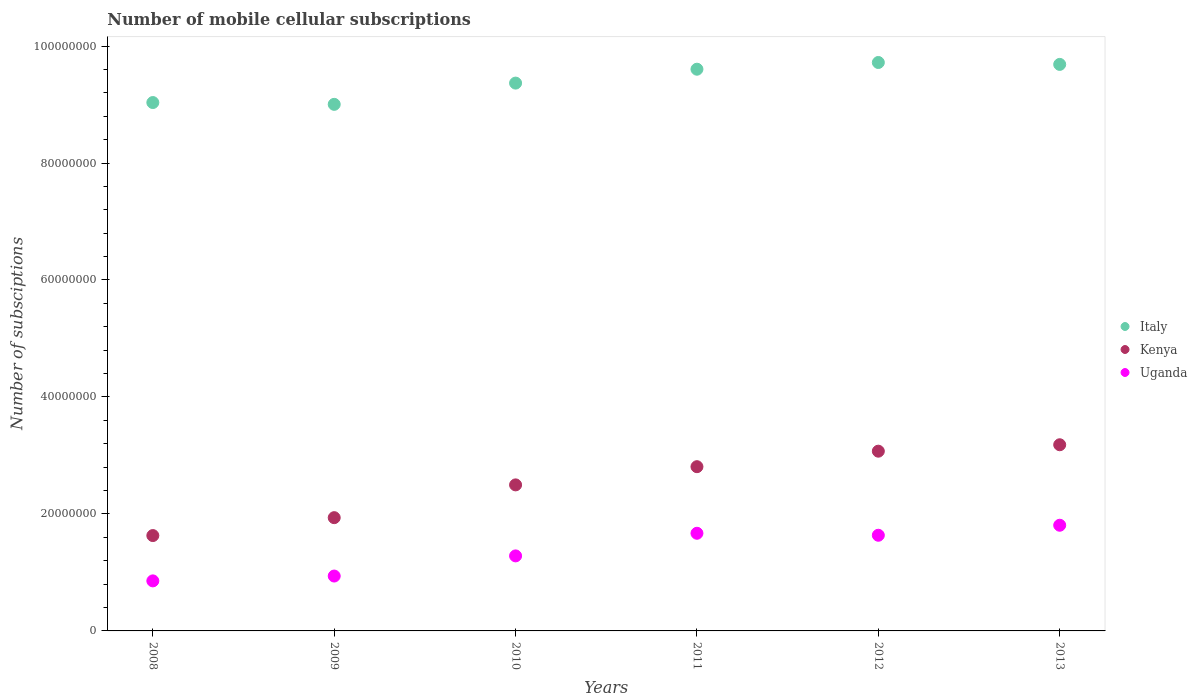How many different coloured dotlines are there?
Offer a very short reply. 3. What is the number of mobile cellular subscriptions in Uganda in 2010?
Keep it short and to the point. 1.28e+07. Across all years, what is the maximum number of mobile cellular subscriptions in Uganda?
Provide a succinct answer. 1.81e+07. Across all years, what is the minimum number of mobile cellular subscriptions in Uganda?
Make the answer very short. 8.55e+06. In which year was the number of mobile cellular subscriptions in Italy minimum?
Give a very brief answer. 2009. What is the total number of mobile cellular subscriptions in Italy in the graph?
Make the answer very short. 5.64e+08. What is the difference between the number of mobile cellular subscriptions in Uganda in 2008 and that in 2013?
Offer a terse response. -9.51e+06. What is the difference between the number of mobile cellular subscriptions in Kenya in 2013 and the number of mobile cellular subscriptions in Uganda in 2009?
Your answer should be very brief. 2.24e+07. What is the average number of mobile cellular subscriptions in Italy per year?
Your response must be concise. 9.40e+07. In the year 2012, what is the difference between the number of mobile cellular subscriptions in Kenya and number of mobile cellular subscriptions in Italy?
Provide a succinct answer. -6.65e+07. In how many years, is the number of mobile cellular subscriptions in Uganda greater than 40000000?
Provide a succinct answer. 0. What is the ratio of the number of mobile cellular subscriptions in Kenya in 2010 to that in 2013?
Give a very brief answer. 0.78. Is the number of mobile cellular subscriptions in Kenya in 2008 less than that in 2010?
Your answer should be very brief. Yes. What is the difference between the highest and the second highest number of mobile cellular subscriptions in Uganda?
Keep it short and to the point. 1.37e+06. What is the difference between the highest and the lowest number of mobile cellular subscriptions in Italy?
Keep it short and to the point. 7.16e+06. In how many years, is the number of mobile cellular subscriptions in Kenya greater than the average number of mobile cellular subscriptions in Kenya taken over all years?
Offer a very short reply. 3. Is the sum of the number of mobile cellular subscriptions in Uganda in 2011 and 2013 greater than the maximum number of mobile cellular subscriptions in Italy across all years?
Keep it short and to the point. No. Is it the case that in every year, the sum of the number of mobile cellular subscriptions in Italy and number of mobile cellular subscriptions in Kenya  is greater than the number of mobile cellular subscriptions in Uganda?
Offer a terse response. Yes. Does the number of mobile cellular subscriptions in Uganda monotonically increase over the years?
Your answer should be compact. No. Is the number of mobile cellular subscriptions in Italy strictly less than the number of mobile cellular subscriptions in Uganda over the years?
Provide a short and direct response. No. How many years are there in the graph?
Your response must be concise. 6. What is the difference between two consecutive major ticks on the Y-axis?
Offer a terse response. 2.00e+07. Are the values on the major ticks of Y-axis written in scientific E-notation?
Keep it short and to the point. No. Does the graph contain any zero values?
Your answer should be very brief. No. How many legend labels are there?
Offer a very short reply. 3. What is the title of the graph?
Provide a succinct answer. Number of mobile cellular subscriptions. What is the label or title of the X-axis?
Provide a short and direct response. Years. What is the label or title of the Y-axis?
Give a very brief answer. Number of subsciptions. What is the Number of subsciptions of Italy in 2008?
Provide a succinct answer. 9.03e+07. What is the Number of subsciptions in Kenya in 2008?
Your answer should be compact. 1.63e+07. What is the Number of subsciptions in Uganda in 2008?
Provide a succinct answer. 8.55e+06. What is the Number of subsciptions of Italy in 2009?
Offer a very short reply. 9.00e+07. What is the Number of subsciptions of Kenya in 2009?
Make the answer very short. 1.94e+07. What is the Number of subsciptions of Uganda in 2009?
Ensure brevity in your answer.  9.38e+06. What is the Number of subsciptions of Italy in 2010?
Your answer should be compact. 9.37e+07. What is the Number of subsciptions of Kenya in 2010?
Provide a succinct answer. 2.50e+07. What is the Number of subsciptions in Uganda in 2010?
Provide a succinct answer. 1.28e+07. What is the Number of subsciptions of Italy in 2011?
Your response must be concise. 9.60e+07. What is the Number of subsciptions in Kenya in 2011?
Provide a short and direct response. 2.81e+07. What is the Number of subsciptions in Uganda in 2011?
Give a very brief answer. 1.67e+07. What is the Number of subsciptions in Italy in 2012?
Your answer should be compact. 9.72e+07. What is the Number of subsciptions of Kenya in 2012?
Ensure brevity in your answer.  3.07e+07. What is the Number of subsciptions of Uganda in 2012?
Your answer should be very brief. 1.64e+07. What is the Number of subsciptions in Italy in 2013?
Make the answer very short. 9.69e+07. What is the Number of subsciptions of Kenya in 2013?
Keep it short and to the point. 3.18e+07. What is the Number of subsciptions of Uganda in 2013?
Your response must be concise. 1.81e+07. Across all years, what is the maximum Number of subsciptions in Italy?
Offer a very short reply. 9.72e+07. Across all years, what is the maximum Number of subsciptions of Kenya?
Your answer should be compact. 3.18e+07. Across all years, what is the maximum Number of subsciptions in Uganda?
Your answer should be very brief. 1.81e+07. Across all years, what is the minimum Number of subsciptions in Italy?
Your answer should be very brief. 9.00e+07. Across all years, what is the minimum Number of subsciptions of Kenya?
Offer a very short reply. 1.63e+07. Across all years, what is the minimum Number of subsciptions in Uganda?
Provide a short and direct response. 8.55e+06. What is the total Number of subsciptions of Italy in the graph?
Your response must be concise. 5.64e+08. What is the total Number of subsciptions in Kenya in the graph?
Keep it short and to the point. 1.51e+08. What is the total Number of subsciptions of Uganda in the graph?
Offer a very short reply. 8.19e+07. What is the difference between the Number of subsciptions in Italy in 2008 and that in 2009?
Your answer should be very brief. 3.08e+05. What is the difference between the Number of subsciptions in Kenya in 2008 and that in 2009?
Give a very brief answer. -3.06e+06. What is the difference between the Number of subsciptions in Uganda in 2008 and that in 2009?
Offer a terse response. -8.29e+05. What is the difference between the Number of subsciptions of Italy in 2008 and that in 2010?
Keep it short and to the point. -3.33e+06. What is the difference between the Number of subsciptions in Kenya in 2008 and that in 2010?
Provide a short and direct response. -8.67e+06. What is the difference between the Number of subsciptions in Uganda in 2008 and that in 2010?
Your response must be concise. -4.27e+06. What is the difference between the Number of subsciptions of Italy in 2008 and that in 2011?
Your answer should be very brief. -5.70e+06. What is the difference between the Number of subsciptions in Kenya in 2008 and that in 2011?
Your response must be concise. -1.18e+07. What is the difference between the Number of subsciptions in Uganda in 2008 and that in 2011?
Make the answer very short. -8.14e+06. What is the difference between the Number of subsciptions in Italy in 2008 and that in 2012?
Provide a short and direct response. -6.85e+06. What is the difference between the Number of subsciptions of Kenya in 2008 and that in 2012?
Give a very brief answer. -1.44e+07. What is the difference between the Number of subsciptions of Uganda in 2008 and that in 2012?
Your answer should be very brief. -7.80e+06. What is the difference between the Number of subsciptions of Italy in 2008 and that in 2013?
Your answer should be very brief. -6.52e+06. What is the difference between the Number of subsciptions of Kenya in 2008 and that in 2013?
Your answer should be compact. -1.55e+07. What is the difference between the Number of subsciptions in Uganda in 2008 and that in 2013?
Your answer should be compact. -9.51e+06. What is the difference between the Number of subsciptions of Italy in 2009 and that in 2010?
Your answer should be compact. -3.63e+06. What is the difference between the Number of subsciptions in Kenya in 2009 and that in 2010?
Ensure brevity in your answer.  -5.60e+06. What is the difference between the Number of subsciptions in Uganda in 2009 and that in 2010?
Provide a succinct answer. -3.44e+06. What is the difference between the Number of subsciptions of Italy in 2009 and that in 2011?
Make the answer very short. -6.01e+06. What is the difference between the Number of subsciptions in Kenya in 2009 and that in 2011?
Your answer should be compact. -8.72e+06. What is the difference between the Number of subsciptions of Uganda in 2009 and that in 2011?
Ensure brevity in your answer.  -7.31e+06. What is the difference between the Number of subsciptions in Italy in 2009 and that in 2012?
Make the answer very short. -7.16e+06. What is the difference between the Number of subsciptions in Kenya in 2009 and that in 2012?
Provide a succinct answer. -1.14e+07. What is the difference between the Number of subsciptions in Uganda in 2009 and that in 2012?
Give a very brief answer. -6.97e+06. What is the difference between the Number of subsciptions in Italy in 2009 and that in 2013?
Your answer should be very brief. -6.83e+06. What is the difference between the Number of subsciptions in Kenya in 2009 and that in 2013?
Offer a terse response. -1.25e+07. What is the difference between the Number of subsciptions in Uganda in 2009 and that in 2013?
Your answer should be very brief. -8.68e+06. What is the difference between the Number of subsciptions of Italy in 2010 and that in 2011?
Keep it short and to the point. -2.37e+06. What is the difference between the Number of subsciptions of Kenya in 2010 and that in 2011?
Your answer should be compact. -3.11e+06. What is the difference between the Number of subsciptions of Uganda in 2010 and that in 2011?
Your response must be concise. -3.87e+06. What is the difference between the Number of subsciptions in Italy in 2010 and that in 2012?
Keep it short and to the point. -3.52e+06. What is the difference between the Number of subsciptions of Kenya in 2010 and that in 2012?
Provide a succinct answer. -5.76e+06. What is the difference between the Number of subsciptions in Uganda in 2010 and that in 2012?
Your response must be concise. -3.53e+06. What is the difference between the Number of subsciptions of Italy in 2010 and that in 2013?
Provide a succinct answer. -3.20e+06. What is the difference between the Number of subsciptions of Kenya in 2010 and that in 2013?
Give a very brief answer. -6.86e+06. What is the difference between the Number of subsciptions in Uganda in 2010 and that in 2013?
Provide a succinct answer. -5.24e+06. What is the difference between the Number of subsciptions in Italy in 2011 and that in 2012?
Provide a succinct answer. -1.15e+06. What is the difference between the Number of subsciptions in Kenya in 2011 and that in 2012?
Offer a very short reply. -2.65e+06. What is the difference between the Number of subsciptions of Uganda in 2011 and that in 2012?
Make the answer very short. 3.41e+05. What is the difference between the Number of subsciptions in Italy in 2011 and that in 2013?
Offer a terse response. -8.22e+05. What is the difference between the Number of subsciptions of Kenya in 2011 and that in 2013?
Provide a short and direct response. -3.75e+06. What is the difference between the Number of subsciptions in Uganda in 2011 and that in 2013?
Your answer should be compact. -1.37e+06. What is the difference between the Number of subsciptions in Italy in 2012 and that in 2013?
Keep it short and to the point. 3.26e+05. What is the difference between the Number of subsciptions in Kenya in 2012 and that in 2013?
Your answer should be very brief. -1.10e+06. What is the difference between the Number of subsciptions of Uganda in 2012 and that in 2013?
Provide a succinct answer. -1.71e+06. What is the difference between the Number of subsciptions of Italy in 2008 and the Number of subsciptions of Kenya in 2009?
Your response must be concise. 7.10e+07. What is the difference between the Number of subsciptions of Italy in 2008 and the Number of subsciptions of Uganda in 2009?
Ensure brevity in your answer.  8.10e+07. What is the difference between the Number of subsciptions in Kenya in 2008 and the Number of subsciptions in Uganda in 2009?
Make the answer very short. 6.92e+06. What is the difference between the Number of subsciptions of Italy in 2008 and the Number of subsciptions of Kenya in 2010?
Make the answer very short. 6.54e+07. What is the difference between the Number of subsciptions in Italy in 2008 and the Number of subsciptions in Uganda in 2010?
Keep it short and to the point. 7.75e+07. What is the difference between the Number of subsciptions in Kenya in 2008 and the Number of subsciptions in Uganda in 2010?
Give a very brief answer. 3.48e+06. What is the difference between the Number of subsciptions in Italy in 2008 and the Number of subsciptions in Kenya in 2011?
Provide a succinct answer. 6.23e+07. What is the difference between the Number of subsciptions in Italy in 2008 and the Number of subsciptions in Uganda in 2011?
Offer a very short reply. 7.36e+07. What is the difference between the Number of subsciptions in Kenya in 2008 and the Number of subsciptions in Uganda in 2011?
Ensure brevity in your answer.  -3.93e+05. What is the difference between the Number of subsciptions of Italy in 2008 and the Number of subsciptions of Kenya in 2012?
Give a very brief answer. 5.96e+07. What is the difference between the Number of subsciptions of Italy in 2008 and the Number of subsciptions of Uganda in 2012?
Make the answer very short. 7.40e+07. What is the difference between the Number of subsciptions of Kenya in 2008 and the Number of subsciptions of Uganda in 2012?
Your response must be concise. -5.28e+04. What is the difference between the Number of subsciptions in Italy in 2008 and the Number of subsciptions in Kenya in 2013?
Your response must be concise. 5.85e+07. What is the difference between the Number of subsciptions in Italy in 2008 and the Number of subsciptions in Uganda in 2013?
Offer a very short reply. 7.23e+07. What is the difference between the Number of subsciptions in Kenya in 2008 and the Number of subsciptions in Uganda in 2013?
Give a very brief answer. -1.77e+06. What is the difference between the Number of subsciptions in Italy in 2009 and the Number of subsciptions in Kenya in 2010?
Your answer should be compact. 6.51e+07. What is the difference between the Number of subsciptions in Italy in 2009 and the Number of subsciptions in Uganda in 2010?
Provide a short and direct response. 7.72e+07. What is the difference between the Number of subsciptions in Kenya in 2009 and the Number of subsciptions in Uganda in 2010?
Keep it short and to the point. 6.54e+06. What is the difference between the Number of subsciptions in Italy in 2009 and the Number of subsciptions in Kenya in 2011?
Your answer should be compact. 6.20e+07. What is the difference between the Number of subsciptions of Italy in 2009 and the Number of subsciptions of Uganda in 2011?
Your answer should be very brief. 7.33e+07. What is the difference between the Number of subsciptions of Kenya in 2009 and the Number of subsciptions of Uganda in 2011?
Provide a succinct answer. 2.67e+06. What is the difference between the Number of subsciptions of Italy in 2009 and the Number of subsciptions of Kenya in 2012?
Ensure brevity in your answer.  5.93e+07. What is the difference between the Number of subsciptions in Italy in 2009 and the Number of subsciptions in Uganda in 2012?
Ensure brevity in your answer.  7.37e+07. What is the difference between the Number of subsciptions in Kenya in 2009 and the Number of subsciptions in Uganda in 2012?
Keep it short and to the point. 3.01e+06. What is the difference between the Number of subsciptions in Italy in 2009 and the Number of subsciptions in Kenya in 2013?
Your answer should be compact. 5.82e+07. What is the difference between the Number of subsciptions of Italy in 2009 and the Number of subsciptions of Uganda in 2013?
Give a very brief answer. 7.20e+07. What is the difference between the Number of subsciptions of Kenya in 2009 and the Number of subsciptions of Uganda in 2013?
Your answer should be compact. 1.30e+06. What is the difference between the Number of subsciptions in Italy in 2010 and the Number of subsciptions in Kenya in 2011?
Your response must be concise. 6.56e+07. What is the difference between the Number of subsciptions of Italy in 2010 and the Number of subsciptions of Uganda in 2011?
Your answer should be compact. 7.70e+07. What is the difference between the Number of subsciptions in Kenya in 2010 and the Number of subsciptions in Uganda in 2011?
Give a very brief answer. 8.27e+06. What is the difference between the Number of subsciptions of Italy in 2010 and the Number of subsciptions of Kenya in 2012?
Your response must be concise. 6.29e+07. What is the difference between the Number of subsciptions in Italy in 2010 and the Number of subsciptions in Uganda in 2012?
Your response must be concise. 7.73e+07. What is the difference between the Number of subsciptions in Kenya in 2010 and the Number of subsciptions in Uganda in 2012?
Offer a very short reply. 8.61e+06. What is the difference between the Number of subsciptions of Italy in 2010 and the Number of subsciptions of Kenya in 2013?
Ensure brevity in your answer.  6.18e+07. What is the difference between the Number of subsciptions of Italy in 2010 and the Number of subsciptions of Uganda in 2013?
Ensure brevity in your answer.  7.56e+07. What is the difference between the Number of subsciptions in Kenya in 2010 and the Number of subsciptions in Uganda in 2013?
Ensure brevity in your answer.  6.90e+06. What is the difference between the Number of subsciptions of Italy in 2011 and the Number of subsciptions of Kenya in 2012?
Keep it short and to the point. 6.53e+07. What is the difference between the Number of subsciptions in Italy in 2011 and the Number of subsciptions in Uganda in 2012?
Ensure brevity in your answer.  7.97e+07. What is the difference between the Number of subsciptions in Kenya in 2011 and the Number of subsciptions in Uganda in 2012?
Make the answer very short. 1.17e+07. What is the difference between the Number of subsciptions of Italy in 2011 and the Number of subsciptions of Kenya in 2013?
Provide a short and direct response. 6.42e+07. What is the difference between the Number of subsciptions of Italy in 2011 and the Number of subsciptions of Uganda in 2013?
Your response must be concise. 7.80e+07. What is the difference between the Number of subsciptions of Kenya in 2011 and the Number of subsciptions of Uganda in 2013?
Your response must be concise. 1.00e+07. What is the difference between the Number of subsciptions of Italy in 2012 and the Number of subsciptions of Kenya in 2013?
Your response must be concise. 6.54e+07. What is the difference between the Number of subsciptions in Italy in 2012 and the Number of subsciptions in Uganda in 2013?
Keep it short and to the point. 7.91e+07. What is the difference between the Number of subsciptions of Kenya in 2012 and the Number of subsciptions of Uganda in 2013?
Provide a short and direct response. 1.27e+07. What is the average Number of subsciptions in Italy per year?
Make the answer very short. 9.40e+07. What is the average Number of subsciptions of Kenya per year?
Your answer should be very brief. 2.52e+07. What is the average Number of subsciptions of Uganda per year?
Your answer should be compact. 1.36e+07. In the year 2008, what is the difference between the Number of subsciptions in Italy and Number of subsciptions in Kenya?
Make the answer very short. 7.40e+07. In the year 2008, what is the difference between the Number of subsciptions of Italy and Number of subsciptions of Uganda?
Your response must be concise. 8.18e+07. In the year 2008, what is the difference between the Number of subsciptions in Kenya and Number of subsciptions in Uganda?
Your response must be concise. 7.75e+06. In the year 2009, what is the difference between the Number of subsciptions in Italy and Number of subsciptions in Kenya?
Your answer should be very brief. 7.07e+07. In the year 2009, what is the difference between the Number of subsciptions of Italy and Number of subsciptions of Uganda?
Make the answer very short. 8.06e+07. In the year 2009, what is the difference between the Number of subsciptions of Kenya and Number of subsciptions of Uganda?
Offer a terse response. 9.98e+06. In the year 2010, what is the difference between the Number of subsciptions in Italy and Number of subsciptions in Kenya?
Offer a terse response. 6.87e+07. In the year 2010, what is the difference between the Number of subsciptions of Italy and Number of subsciptions of Uganda?
Offer a very short reply. 8.08e+07. In the year 2010, what is the difference between the Number of subsciptions in Kenya and Number of subsciptions in Uganda?
Make the answer very short. 1.21e+07. In the year 2011, what is the difference between the Number of subsciptions of Italy and Number of subsciptions of Kenya?
Your response must be concise. 6.80e+07. In the year 2011, what is the difference between the Number of subsciptions of Italy and Number of subsciptions of Uganda?
Offer a terse response. 7.93e+07. In the year 2011, what is the difference between the Number of subsciptions of Kenya and Number of subsciptions of Uganda?
Ensure brevity in your answer.  1.14e+07. In the year 2012, what is the difference between the Number of subsciptions of Italy and Number of subsciptions of Kenya?
Your response must be concise. 6.65e+07. In the year 2012, what is the difference between the Number of subsciptions in Italy and Number of subsciptions in Uganda?
Provide a succinct answer. 8.08e+07. In the year 2012, what is the difference between the Number of subsciptions in Kenya and Number of subsciptions in Uganda?
Make the answer very short. 1.44e+07. In the year 2013, what is the difference between the Number of subsciptions of Italy and Number of subsciptions of Kenya?
Your answer should be very brief. 6.50e+07. In the year 2013, what is the difference between the Number of subsciptions of Italy and Number of subsciptions of Uganda?
Your answer should be compact. 7.88e+07. In the year 2013, what is the difference between the Number of subsciptions of Kenya and Number of subsciptions of Uganda?
Make the answer very short. 1.38e+07. What is the ratio of the Number of subsciptions in Kenya in 2008 to that in 2009?
Provide a succinct answer. 0.84. What is the ratio of the Number of subsciptions in Uganda in 2008 to that in 2009?
Your response must be concise. 0.91. What is the ratio of the Number of subsciptions of Italy in 2008 to that in 2010?
Offer a terse response. 0.96. What is the ratio of the Number of subsciptions in Kenya in 2008 to that in 2010?
Provide a short and direct response. 0.65. What is the ratio of the Number of subsciptions in Uganda in 2008 to that in 2010?
Make the answer very short. 0.67. What is the ratio of the Number of subsciptions in Italy in 2008 to that in 2011?
Your answer should be compact. 0.94. What is the ratio of the Number of subsciptions of Kenya in 2008 to that in 2011?
Offer a very short reply. 0.58. What is the ratio of the Number of subsciptions in Uganda in 2008 to that in 2011?
Provide a short and direct response. 0.51. What is the ratio of the Number of subsciptions of Italy in 2008 to that in 2012?
Make the answer very short. 0.93. What is the ratio of the Number of subsciptions of Kenya in 2008 to that in 2012?
Ensure brevity in your answer.  0.53. What is the ratio of the Number of subsciptions in Uganda in 2008 to that in 2012?
Your response must be concise. 0.52. What is the ratio of the Number of subsciptions in Italy in 2008 to that in 2013?
Provide a short and direct response. 0.93. What is the ratio of the Number of subsciptions of Kenya in 2008 to that in 2013?
Provide a short and direct response. 0.51. What is the ratio of the Number of subsciptions in Uganda in 2008 to that in 2013?
Keep it short and to the point. 0.47. What is the ratio of the Number of subsciptions of Italy in 2009 to that in 2010?
Give a very brief answer. 0.96. What is the ratio of the Number of subsciptions of Kenya in 2009 to that in 2010?
Your answer should be very brief. 0.78. What is the ratio of the Number of subsciptions in Uganda in 2009 to that in 2010?
Give a very brief answer. 0.73. What is the ratio of the Number of subsciptions in Italy in 2009 to that in 2011?
Provide a short and direct response. 0.94. What is the ratio of the Number of subsciptions of Kenya in 2009 to that in 2011?
Offer a very short reply. 0.69. What is the ratio of the Number of subsciptions in Uganda in 2009 to that in 2011?
Provide a succinct answer. 0.56. What is the ratio of the Number of subsciptions in Italy in 2009 to that in 2012?
Make the answer very short. 0.93. What is the ratio of the Number of subsciptions in Kenya in 2009 to that in 2012?
Your answer should be compact. 0.63. What is the ratio of the Number of subsciptions of Uganda in 2009 to that in 2012?
Offer a very short reply. 0.57. What is the ratio of the Number of subsciptions in Italy in 2009 to that in 2013?
Offer a very short reply. 0.93. What is the ratio of the Number of subsciptions of Kenya in 2009 to that in 2013?
Your response must be concise. 0.61. What is the ratio of the Number of subsciptions of Uganda in 2009 to that in 2013?
Your response must be concise. 0.52. What is the ratio of the Number of subsciptions in Italy in 2010 to that in 2011?
Make the answer very short. 0.98. What is the ratio of the Number of subsciptions of Kenya in 2010 to that in 2011?
Your answer should be compact. 0.89. What is the ratio of the Number of subsciptions in Uganda in 2010 to that in 2011?
Provide a succinct answer. 0.77. What is the ratio of the Number of subsciptions of Italy in 2010 to that in 2012?
Your response must be concise. 0.96. What is the ratio of the Number of subsciptions of Kenya in 2010 to that in 2012?
Offer a very short reply. 0.81. What is the ratio of the Number of subsciptions of Uganda in 2010 to that in 2012?
Ensure brevity in your answer.  0.78. What is the ratio of the Number of subsciptions in Italy in 2010 to that in 2013?
Provide a short and direct response. 0.97. What is the ratio of the Number of subsciptions in Kenya in 2010 to that in 2013?
Give a very brief answer. 0.78. What is the ratio of the Number of subsciptions of Uganda in 2010 to that in 2013?
Ensure brevity in your answer.  0.71. What is the ratio of the Number of subsciptions of Italy in 2011 to that in 2012?
Your response must be concise. 0.99. What is the ratio of the Number of subsciptions of Kenya in 2011 to that in 2012?
Provide a short and direct response. 0.91. What is the ratio of the Number of subsciptions of Uganda in 2011 to that in 2012?
Provide a short and direct response. 1.02. What is the ratio of the Number of subsciptions of Italy in 2011 to that in 2013?
Make the answer very short. 0.99. What is the ratio of the Number of subsciptions of Kenya in 2011 to that in 2013?
Your answer should be compact. 0.88. What is the ratio of the Number of subsciptions of Uganda in 2011 to that in 2013?
Your response must be concise. 0.92. What is the ratio of the Number of subsciptions of Italy in 2012 to that in 2013?
Your answer should be very brief. 1. What is the ratio of the Number of subsciptions in Kenya in 2012 to that in 2013?
Offer a very short reply. 0.97. What is the ratio of the Number of subsciptions in Uganda in 2012 to that in 2013?
Provide a succinct answer. 0.91. What is the difference between the highest and the second highest Number of subsciptions in Italy?
Provide a short and direct response. 3.26e+05. What is the difference between the highest and the second highest Number of subsciptions of Kenya?
Provide a succinct answer. 1.10e+06. What is the difference between the highest and the second highest Number of subsciptions of Uganda?
Provide a short and direct response. 1.37e+06. What is the difference between the highest and the lowest Number of subsciptions of Italy?
Your answer should be compact. 7.16e+06. What is the difference between the highest and the lowest Number of subsciptions in Kenya?
Provide a succinct answer. 1.55e+07. What is the difference between the highest and the lowest Number of subsciptions in Uganda?
Your answer should be very brief. 9.51e+06. 